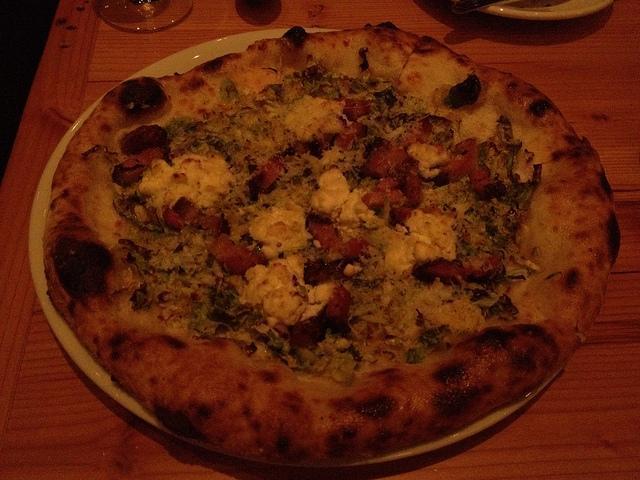How many silver cars are in the image?
Give a very brief answer. 0. 